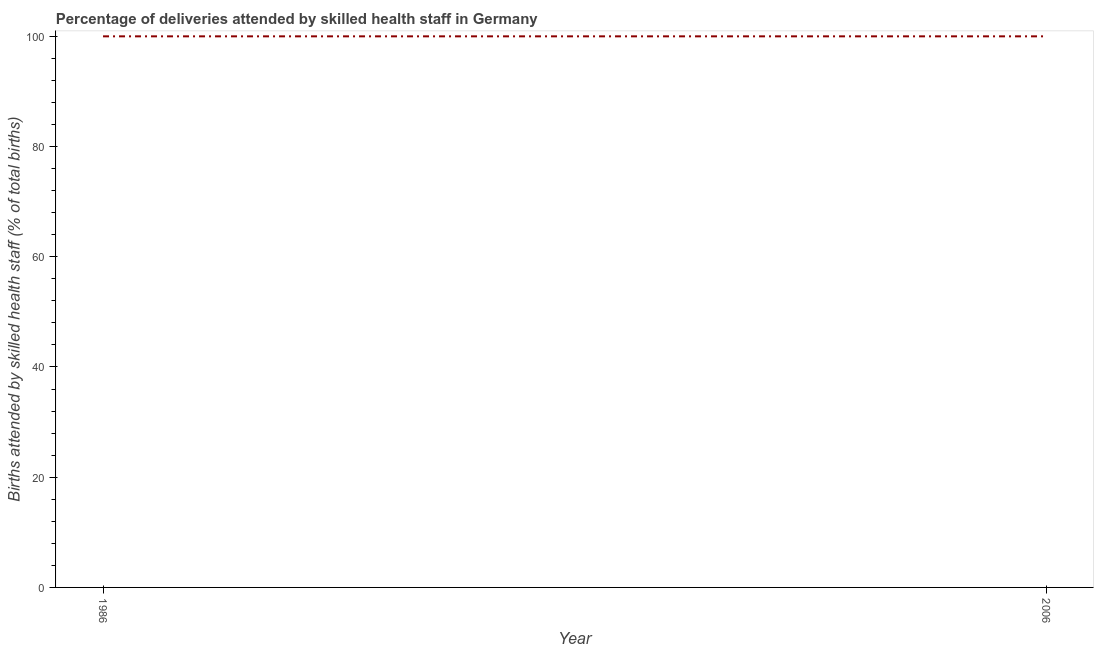What is the number of births attended by skilled health staff in 2006?
Keep it short and to the point. 100. Across all years, what is the maximum number of births attended by skilled health staff?
Keep it short and to the point. 100. Across all years, what is the minimum number of births attended by skilled health staff?
Your response must be concise. 100. In which year was the number of births attended by skilled health staff maximum?
Offer a terse response. 1986. In which year was the number of births attended by skilled health staff minimum?
Your answer should be very brief. 1986. What is the sum of the number of births attended by skilled health staff?
Provide a succinct answer. 200. What is the difference between the number of births attended by skilled health staff in 1986 and 2006?
Your response must be concise. 0. What is the average number of births attended by skilled health staff per year?
Provide a short and direct response. 100. In how many years, is the number of births attended by skilled health staff greater than 48 %?
Give a very brief answer. 2. What is the difference between two consecutive major ticks on the Y-axis?
Offer a very short reply. 20. Are the values on the major ticks of Y-axis written in scientific E-notation?
Your answer should be very brief. No. Does the graph contain any zero values?
Provide a succinct answer. No. Does the graph contain grids?
Keep it short and to the point. No. What is the title of the graph?
Keep it short and to the point. Percentage of deliveries attended by skilled health staff in Germany. What is the label or title of the X-axis?
Offer a very short reply. Year. What is the label or title of the Y-axis?
Offer a terse response. Births attended by skilled health staff (% of total births). What is the Births attended by skilled health staff (% of total births) in 1986?
Offer a terse response. 100. What is the ratio of the Births attended by skilled health staff (% of total births) in 1986 to that in 2006?
Your answer should be very brief. 1. 